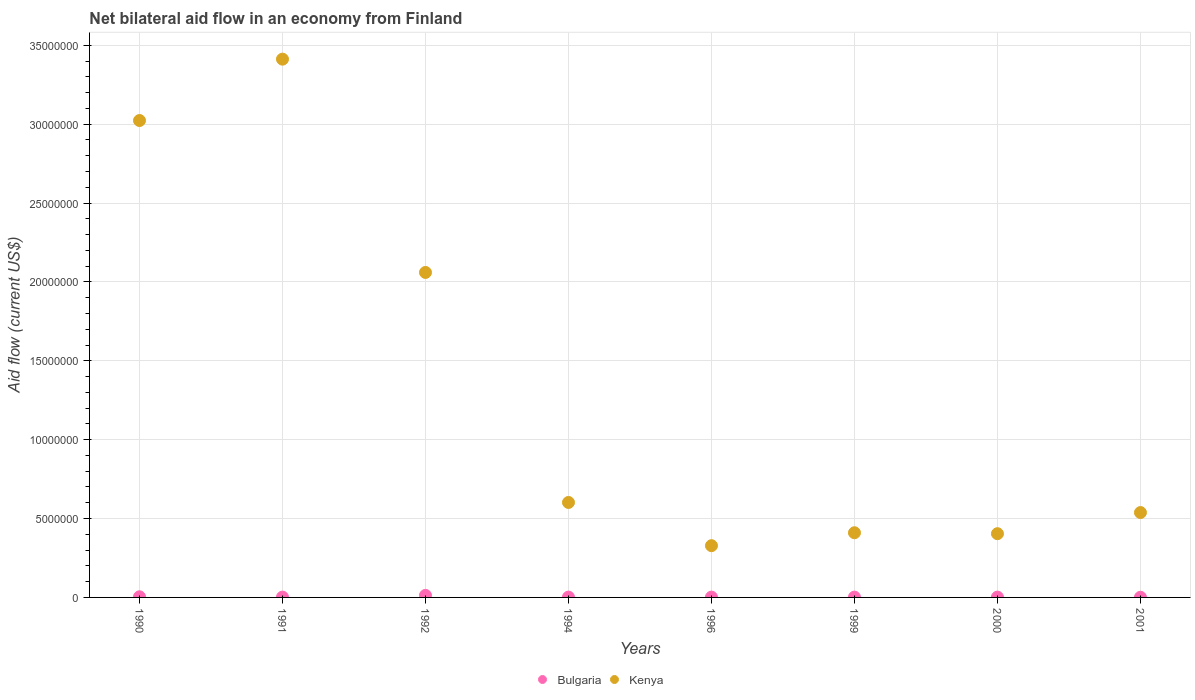How many different coloured dotlines are there?
Keep it short and to the point. 2. What is the net bilateral aid flow in Kenya in 1996?
Your response must be concise. 3.28e+06. Across all years, what is the maximum net bilateral aid flow in Bulgaria?
Make the answer very short. 1.30e+05. Across all years, what is the minimum net bilateral aid flow in Kenya?
Offer a very short reply. 3.28e+06. In which year was the net bilateral aid flow in Kenya maximum?
Provide a succinct answer. 1991. In which year was the net bilateral aid flow in Bulgaria minimum?
Offer a very short reply. 2001. What is the total net bilateral aid flow in Kenya in the graph?
Provide a short and direct response. 1.08e+08. What is the difference between the net bilateral aid flow in Bulgaria in 1994 and the net bilateral aid flow in Kenya in 1990?
Offer a terse response. -3.02e+07. What is the average net bilateral aid flow in Kenya per year?
Make the answer very short. 1.35e+07. In the year 2000, what is the difference between the net bilateral aid flow in Bulgaria and net bilateral aid flow in Kenya?
Make the answer very short. -4.02e+06. In how many years, is the net bilateral aid flow in Kenya greater than 33000000 US$?
Provide a succinct answer. 1. What is the ratio of the net bilateral aid flow in Kenya in 1999 to that in 2001?
Your response must be concise. 0.76. Is the difference between the net bilateral aid flow in Bulgaria in 1994 and 2001 greater than the difference between the net bilateral aid flow in Kenya in 1994 and 2001?
Provide a succinct answer. No. What is the difference between the highest and the second highest net bilateral aid flow in Bulgaria?
Ensure brevity in your answer.  9.00e+04. What is the difference between the highest and the lowest net bilateral aid flow in Kenya?
Make the answer very short. 3.08e+07. In how many years, is the net bilateral aid flow in Bulgaria greater than the average net bilateral aid flow in Bulgaria taken over all years?
Your answer should be compact. 2. Is the sum of the net bilateral aid flow in Kenya in 1996 and 1999 greater than the maximum net bilateral aid flow in Bulgaria across all years?
Offer a terse response. Yes. Does the net bilateral aid flow in Bulgaria monotonically increase over the years?
Your answer should be very brief. No. Is the net bilateral aid flow in Bulgaria strictly less than the net bilateral aid flow in Kenya over the years?
Your response must be concise. Yes. How many years are there in the graph?
Offer a very short reply. 8. Are the values on the major ticks of Y-axis written in scientific E-notation?
Offer a very short reply. No. Does the graph contain grids?
Provide a short and direct response. Yes. What is the title of the graph?
Your answer should be very brief. Net bilateral aid flow in an economy from Finland. What is the Aid flow (current US$) of Bulgaria in 1990?
Your response must be concise. 4.00e+04. What is the Aid flow (current US$) in Kenya in 1990?
Give a very brief answer. 3.02e+07. What is the Aid flow (current US$) of Bulgaria in 1991?
Ensure brevity in your answer.  2.00e+04. What is the Aid flow (current US$) in Kenya in 1991?
Make the answer very short. 3.41e+07. What is the Aid flow (current US$) of Bulgaria in 1992?
Your answer should be compact. 1.30e+05. What is the Aid flow (current US$) in Kenya in 1992?
Ensure brevity in your answer.  2.06e+07. What is the Aid flow (current US$) in Bulgaria in 1994?
Your answer should be compact. 2.00e+04. What is the Aid flow (current US$) of Kenya in 1994?
Provide a short and direct response. 6.02e+06. What is the Aid flow (current US$) in Kenya in 1996?
Make the answer very short. 3.28e+06. What is the Aid flow (current US$) of Kenya in 1999?
Give a very brief answer. 4.10e+06. What is the Aid flow (current US$) of Kenya in 2000?
Keep it short and to the point. 4.04e+06. What is the Aid flow (current US$) in Kenya in 2001?
Provide a succinct answer. 5.38e+06. Across all years, what is the maximum Aid flow (current US$) in Kenya?
Your answer should be compact. 3.41e+07. Across all years, what is the minimum Aid flow (current US$) in Kenya?
Your response must be concise. 3.28e+06. What is the total Aid flow (current US$) in Kenya in the graph?
Your answer should be compact. 1.08e+08. What is the difference between the Aid flow (current US$) of Bulgaria in 1990 and that in 1991?
Ensure brevity in your answer.  2.00e+04. What is the difference between the Aid flow (current US$) of Kenya in 1990 and that in 1991?
Offer a very short reply. -3.89e+06. What is the difference between the Aid flow (current US$) of Kenya in 1990 and that in 1992?
Make the answer very short. 9.63e+06. What is the difference between the Aid flow (current US$) in Bulgaria in 1990 and that in 1994?
Your answer should be very brief. 2.00e+04. What is the difference between the Aid flow (current US$) of Kenya in 1990 and that in 1994?
Provide a short and direct response. 2.42e+07. What is the difference between the Aid flow (current US$) of Kenya in 1990 and that in 1996?
Your answer should be very brief. 2.70e+07. What is the difference between the Aid flow (current US$) in Kenya in 1990 and that in 1999?
Offer a terse response. 2.61e+07. What is the difference between the Aid flow (current US$) of Bulgaria in 1990 and that in 2000?
Keep it short and to the point. 2.00e+04. What is the difference between the Aid flow (current US$) in Kenya in 1990 and that in 2000?
Your response must be concise. 2.62e+07. What is the difference between the Aid flow (current US$) in Kenya in 1990 and that in 2001?
Offer a very short reply. 2.48e+07. What is the difference between the Aid flow (current US$) of Bulgaria in 1991 and that in 1992?
Your answer should be compact. -1.10e+05. What is the difference between the Aid flow (current US$) of Kenya in 1991 and that in 1992?
Make the answer very short. 1.35e+07. What is the difference between the Aid flow (current US$) of Bulgaria in 1991 and that in 1994?
Make the answer very short. 0. What is the difference between the Aid flow (current US$) of Kenya in 1991 and that in 1994?
Your response must be concise. 2.81e+07. What is the difference between the Aid flow (current US$) of Bulgaria in 1991 and that in 1996?
Your response must be concise. 0. What is the difference between the Aid flow (current US$) of Kenya in 1991 and that in 1996?
Provide a succinct answer. 3.08e+07. What is the difference between the Aid flow (current US$) in Bulgaria in 1991 and that in 1999?
Make the answer very short. 0. What is the difference between the Aid flow (current US$) in Kenya in 1991 and that in 1999?
Provide a short and direct response. 3.00e+07. What is the difference between the Aid flow (current US$) of Bulgaria in 1991 and that in 2000?
Your answer should be very brief. 0. What is the difference between the Aid flow (current US$) of Kenya in 1991 and that in 2000?
Your answer should be very brief. 3.01e+07. What is the difference between the Aid flow (current US$) of Kenya in 1991 and that in 2001?
Your response must be concise. 2.87e+07. What is the difference between the Aid flow (current US$) of Bulgaria in 1992 and that in 1994?
Offer a very short reply. 1.10e+05. What is the difference between the Aid flow (current US$) in Kenya in 1992 and that in 1994?
Your response must be concise. 1.46e+07. What is the difference between the Aid flow (current US$) in Kenya in 1992 and that in 1996?
Make the answer very short. 1.73e+07. What is the difference between the Aid flow (current US$) in Kenya in 1992 and that in 1999?
Provide a short and direct response. 1.65e+07. What is the difference between the Aid flow (current US$) of Kenya in 1992 and that in 2000?
Offer a terse response. 1.66e+07. What is the difference between the Aid flow (current US$) in Kenya in 1992 and that in 2001?
Your answer should be compact. 1.52e+07. What is the difference between the Aid flow (current US$) in Kenya in 1994 and that in 1996?
Provide a succinct answer. 2.74e+06. What is the difference between the Aid flow (current US$) of Kenya in 1994 and that in 1999?
Your answer should be compact. 1.92e+06. What is the difference between the Aid flow (current US$) in Kenya in 1994 and that in 2000?
Offer a terse response. 1.98e+06. What is the difference between the Aid flow (current US$) in Kenya in 1994 and that in 2001?
Offer a very short reply. 6.40e+05. What is the difference between the Aid flow (current US$) of Kenya in 1996 and that in 1999?
Make the answer very short. -8.20e+05. What is the difference between the Aid flow (current US$) in Bulgaria in 1996 and that in 2000?
Keep it short and to the point. 0. What is the difference between the Aid flow (current US$) in Kenya in 1996 and that in 2000?
Ensure brevity in your answer.  -7.60e+05. What is the difference between the Aid flow (current US$) of Bulgaria in 1996 and that in 2001?
Your answer should be compact. 10000. What is the difference between the Aid flow (current US$) of Kenya in 1996 and that in 2001?
Provide a succinct answer. -2.10e+06. What is the difference between the Aid flow (current US$) in Bulgaria in 1999 and that in 2000?
Make the answer very short. 0. What is the difference between the Aid flow (current US$) of Kenya in 1999 and that in 2001?
Your answer should be compact. -1.28e+06. What is the difference between the Aid flow (current US$) of Kenya in 2000 and that in 2001?
Ensure brevity in your answer.  -1.34e+06. What is the difference between the Aid flow (current US$) in Bulgaria in 1990 and the Aid flow (current US$) in Kenya in 1991?
Provide a succinct answer. -3.41e+07. What is the difference between the Aid flow (current US$) of Bulgaria in 1990 and the Aid flow (current US$) of Kenya in 1992?
Offer a terse response. -2.06e+07. What is the difference between the Aid flow (current US$) in Bulgaria in 1990 and the Aid flow (current US$) in Kenya in 1994?
Offer a very short reply. -5.98e+06. What is the difference between the Aid flow (current US$) in Bulgaria in 1990 and the Aid flow (current US$) in Kenya in 1996?
Your answer should be very brief. -3.24e+06. What is the difference between the Aid flow (current US$) in Bulgaria in 1990 and the Aid flow (current US$) in Kenya in 1999?
Keep it short and to the point. -4.06e+06. What is the difference between the Aid flow (current US$) of Bulgaria in 1990 and the Aid flow (current US$) of Kenya in 2001?
Offer a terse response. -5.34e+06. What is the difference between the Aid flow (current US$) of Bulgaria in 1991 and the Aid flow (current US$) of Kenya in 1992?
Make the answer very short. -2.06e+07. What is the difference between the Aid flow (current US$) of Bulgaria in 1991 and the Aid flow (current US$) of Kenya in 1994?
Make the answer very short. -6.00e+06. What is the difference between the Aid flow (current US$) in Bulgaria in 1991 and the Aid flow (current US$) in Kenya in 1996?
Offer a very short reply. -3.26e+06. What is the difference between the Aid flow (current US$) of Bulgaria in 1991 and the Aid flow (current US$) of Kenya in 1999?
Provide a short and direct response. -4.08e+06. What is the difference between the Aid flow (current US$) of Bulgaria in 1991 and the Aid flow (current US$) of Kenya in 2000?
Keep it short and to the point. -4.02e+06. What is the difference between the Aid flow (current US$) of Bulgaria in 1991 and the Aid flow (current US$) of Kenya in 2001?
Offer a very short reply. -5.36e+06. What is the difference between the Aid flow (current US$) in Bulgaria in 1992 and the Aid flow (current US$) in Kenya in 1994?
Offer a very short reply. -5.89e+06. What is the difference between the Aid flow (current US$) of Bulgaria in 1992 and the Aid flow (current US$) of Kenya in 1996?
Provide a succinct answer. -3.15e+06. What is the difference between the Aid flow (current US$) of Bulgaria in 1992 and the Aid flow (current US$) of Kenya in 1999?
Your response must be concise. -3.97e+06. What is the difference between the Aid flow (current US$) in Bulgaria in 1992 and the Aid flow (current US$) in Kenya in 2000?
Offer a terse response. -3.91e+06. What is the difference between the Aid flow (current US$) of Bulgaria in 1992 and the Aid flow (current US$) of Kenya in 2001?
Offer a very short reply. -5.25e+06. What is the difference between the Aid flow (current US$) in Bulgaria in 1994 and the Aid flow (current US$) in Kenya in 1996?
Your answer should be very brief. -3.26e+06. What is the difference between the Aid flow (current US$) of Bulgaria in 1994 and the Aid flow (current US$) of Kenya in 1999?
Your answer should be very brief. -4.08e+06. What is the difference between the Aid flow (current US$) in Bulgaria in 1994 and the Aid flow (current US$) in Kenya in 2000?
Ensure brevity in your answer.  -4.02e+06. What is the difference between the Aid flow (current US$) of Bulgaria in 1994 and the Aid flow (current US$) of Kenya in 2001?
Give a very brief answer. -5.36e+06. What is the difference between the Aid flow (current US$) of Bulgaria in 1996 and the Aid flow (current US$) of Kenya in 1999?
Give a very brief answer. -4.08e+06. What is the difference between the Aid flow (current US$) of Bulgaria in 1996 and the Aid flow (current US$) of Kenya in 2000?
Provide a short and direct response. -4.02e+06. What is the difference between the Aid flow (current US$) of Bulgaria in 1996 and the Aid flow (current US$) of Kenya in 2001?
Ensure brevity in your answer.  -5.36e+06. What is the difference between the Aid flow (current US$) in Bulgaria in 1999 and the Aid flow (current US$) in Kenya in 2000?
Provide a succinct answer. -4.02e+06. What is the difference between the Aid flow (current US$) of Bulgaria in 1999 and the Aid flow (current US$) of Kenya in 2001?
Make the answer very short. -5.36e+06. What is the difference between the Aid flow (current US$) in Bulgaria in 2000 and the Aid flow (current US$) in Kenya in 2001?
Your response must be concise. -5.36e+06. What is the average Aid flow (current US$) in Bulgaria per year?
Offer a very short reply. 3.50e+04. What is the average Aid flow (current US$) in Kenya per year?
Your answer should be very brief. 1.35e+07. In the year 1990, what is the difference between the Aid flow (current US$) of Bulgaria and Aid flow (current US$) of Kenya?
Offer a very short reply. -3.02e+07. In the year 1991, what is the difference between the Aid flow (current US$) in Bulgaria and Aid flow (current US$) in Kenya?
Give a very brief answer. -3.41e+07. In the year 1992, what is the difference between the Aid flow (current US$) of Bulgaria and Aid flow (current US$) of Kenya?
Give a very brief answer. -2.05e+07. In the year 1994, what is the difference between the Aid flow (current US$) in Bulgaria and Aid flow (current US$) in Kenya?
Your answer should be compact. -6.00e+06. In the year 1996, what is the difference between the Aid flow (current US$) in Bulgaria and Aid flow (current US$) in Kenya?
Offer a very short reply. -3.26e+06. In the year 1999, what is the difference between the Aid flow (current US$) in Bulgaria and Aid flow (current US$) in Kenya?
Give a very brief answer. -4.08e+06. In the year 2000, what is the difference between the Aid flow (current US$) of Bulgaria and Aid flow (current US$) of Kenya?
Your answer should be very brief. -4.02e+06. In the year 2001, what is the difference between the Aid flow (current US$) of Bulgaria and Aid flow (current US$) of Kenya?
Your answer should be very brief. -5.37e+06. What is the ratio of the Aid flow (current US$) in Bulgaria in 1990 to that in 1991?
Your answer should be very brief. 2. What is the ratio of the Aid flow (current US$) in Kenya in 1990 to that in 1991?
Provide a short and direct response. 0.89. What is the ratio of the Aid flow (current US$) in Bulgaria in 1990 to that in 1992?
Provide a succinct answer. 0.31. What is the ratio of the Aid flow (current US$) of Kenya in 1990 to that in 1992?
Offer a very short reply. 1.47. What is the ratio of the Aid flow (current US$) in Kenya in 1990 to that in 1994?
Your answer should be very brief. 5.02. What is the ratio of the Aid flow (current US$) of Bulgaria in 1990 to that in 1996?
Provide a succinct answer. 2. What is the ratio of the Aid flow (current US$) of Kenya in 1990 to that in 1996?
Make the answer very short. 9.22. What is the ratio of the Aid flow (current US$) in Bulgaria in 1990 to that in 1999?
Your answer should be very brief. 2. What is the ratio of the Aid flow (current US$) of Kenya in 1990 to that in 1999?
Make the answer very short. 7.37. What is the ratio of the Aid flow (current US$) in Kenya in 1990 to that in 2000?
Offer a terse response. 7.48. What is the ratio of the Aid flow (current US$) of Bulgaria in 1990 to that in 2001?
Offer a very short reply. 4. What is the ratio of the Aid flow (current US$) in Kenya in 1990 to that in 2001?
Keep it short and to the point. 5.62. What is the ratio of the Aid flow (current US$) of Bulgaria in 1991 to that in 1992?
Your answer should be compact. 0.15. What is the ratio of the Aid flow (current US$) of Kenya in 1991 to that in 1992?
Provide a succinct answer. 1.66. What is the ratio of the Aid flow (current US$) of Bulgaria in 1991 to that in 1994?
Give a very brief answer. 1. What is the ratio of the Aid flow (current US$) of Kenya in 1991 to that in 1994?
Offer a terse response. 5.67. What is the ratio of the Aid flow (current US$) in Bulgaria in 1991 to that in 1996?
Keep it short and to the point. 1. What is the ratio of the Aid flow (current US$) in Kenya in 1991 to that in 1996?
Ensure brevity in your answer.  10.4. What is the ratio of the Aid flow (current US$) of Bulgaria in 1991 to that in 1999?
Offer a very short reply. 1. What is the ratio of the Aid flow (current US$) of Kenya in 1991 to that in 1999?
Provide a succinct answer. 8.32. What is the ratio of the Aid flow (current US$) in Kenya in 1991 to that in 2000?
Make the answer very short. 8.45. What is the ratio of the Aid flow (current US$) of Bulgaria in 1991 to that in 2001?
Provide a succinct answer. 2. What is the ratio of the Aid flow (current US$) of Kenya in 1991 to that in 2001?
Make the answer very short. 6.34. What is the ratio of the Aid flow (current US$) in Kenya in 1992 to that in 1994?
Your response must be concise. 3.42. What is the ratio of the Aid flow (current US$) of Bulgaria in 1992 to that in 1996?
Your answer should be very brief. 6.5. What is the ratio of the Aid flow (current US$) of Kenya in 1992 to that in 1996?
Offer a very short reply. 6.28. What is the ratio of the Aid flow (current US$) of Kenya in 1992 to that in 1999?
Ensure brevity in your answer.  5.02. What is the ratio of the Aid flow (current US$) in Kenya in 1992 to that in 2000?
Your response must be concise. 5.1. What is the ratio of the Aid flow (current US$) in Kenya in 1992 to that in 2001?
Your answer should be very brief. 3.83. What is the ratio of the Aid flow (current US$) in Bulgaria in 1994 to that in 1996?
Give a very brief answer. 1. What is the ratio of the Aid flow (current US$) of Kenya in 1994 to that in 1996?
Make the answer very short. 1.84. What is the ratio of the Aid flow (current US$) of Bulgaria in 1994 to that in 1999?
Provide a short and direct response. 1. What is the ratio of the Aid flow (current US$) of Kenya in 1994 to that in 1999?
Offer a very short reply. 1.47. What is the ratio of the Aid flow (current US$) of Bulgaria in 1994 to that in 2000?
Make the answer very short. 1. What is the ratio of the Aid flow (current US$) of Kenya in 1994 to that in 2000?
Your answer should be very brief. 1.49. What is the ratio of the Aid flow (current US$) in Bulgaria in 1994 to that in 2001?
Give a very brief answer. 2. What is the ratio of the Aid flow (current US$) in Kenya in 1994 to that in 2001?
Keep it short and to the point. 1.12. What is the ratio of the Aid flow (current US$) in Bulgaria in 1996 to that in 1999?
Your response must be concise. 1. What is the ratio of the Aid flow (current US$) of Kenya in 1996 to that in 2000?
Provide a succinct answer. 0.81. What is the ratio of the Aid flow (current US$) of Kenya in 1996 to that in 2001?
Provide a short and direct response. 0.61. What is the ratio of the Aid flow (current US$) in Kenya in 1999 to that in 2000?
Provide a short and direct response. 1.01. What is the ratio of the Aid flow (current US$) of Kenya in 1999 to that in 2001?
Give a very brief answer. 0.76. What is the ratio of the Aid flow (current US$) of Bulgaria in 2000 to that in 2001?
Provide a short and direct response. 2. What is the ratio of the Aid flow (current US$) in Kenya in 2000 to that in 2001?
Your answer should be compact. 0.75. What is the difference between the highest and the second highest Aid flow (current US$) of Bulgaria?
Your answer should be very brief. 9.00e+04. What is the difference between the highest and the second highest Aid flow (current US$) of Kenya?
Your answer should be very brief. 3.89e+06. What is the difference between the highest and the lowest Aid flow (current US$) of Bulgaria?
Make the answer very short. 1.20e+05. What is the difference between the highest and the lowest Aid flow (current US$) of Kenya?
Your answer should be compact. 3.08e+07. 